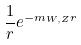<formula> <loc_0><loc_0><loc_500><loc_500>\frac { 1 } { r } e ^ { - m _ { W , Z } r }</formula> 